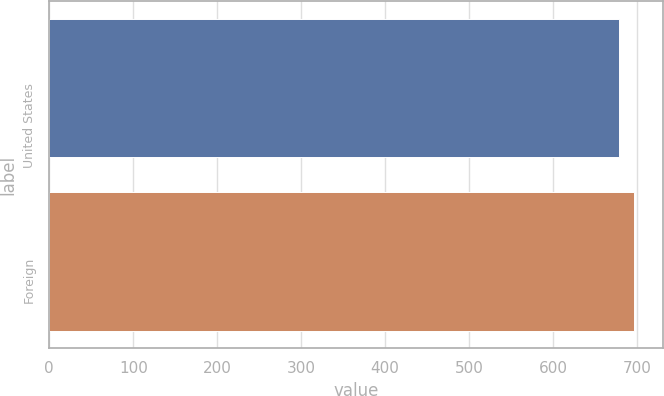Convert chart to OTSL. <chart><loc_0><loc_0><loc_500><loc_500><bar_chart><fcel>United States<fcel>Foreign<nl><fcel>678<fcel>696<nl></chart> 